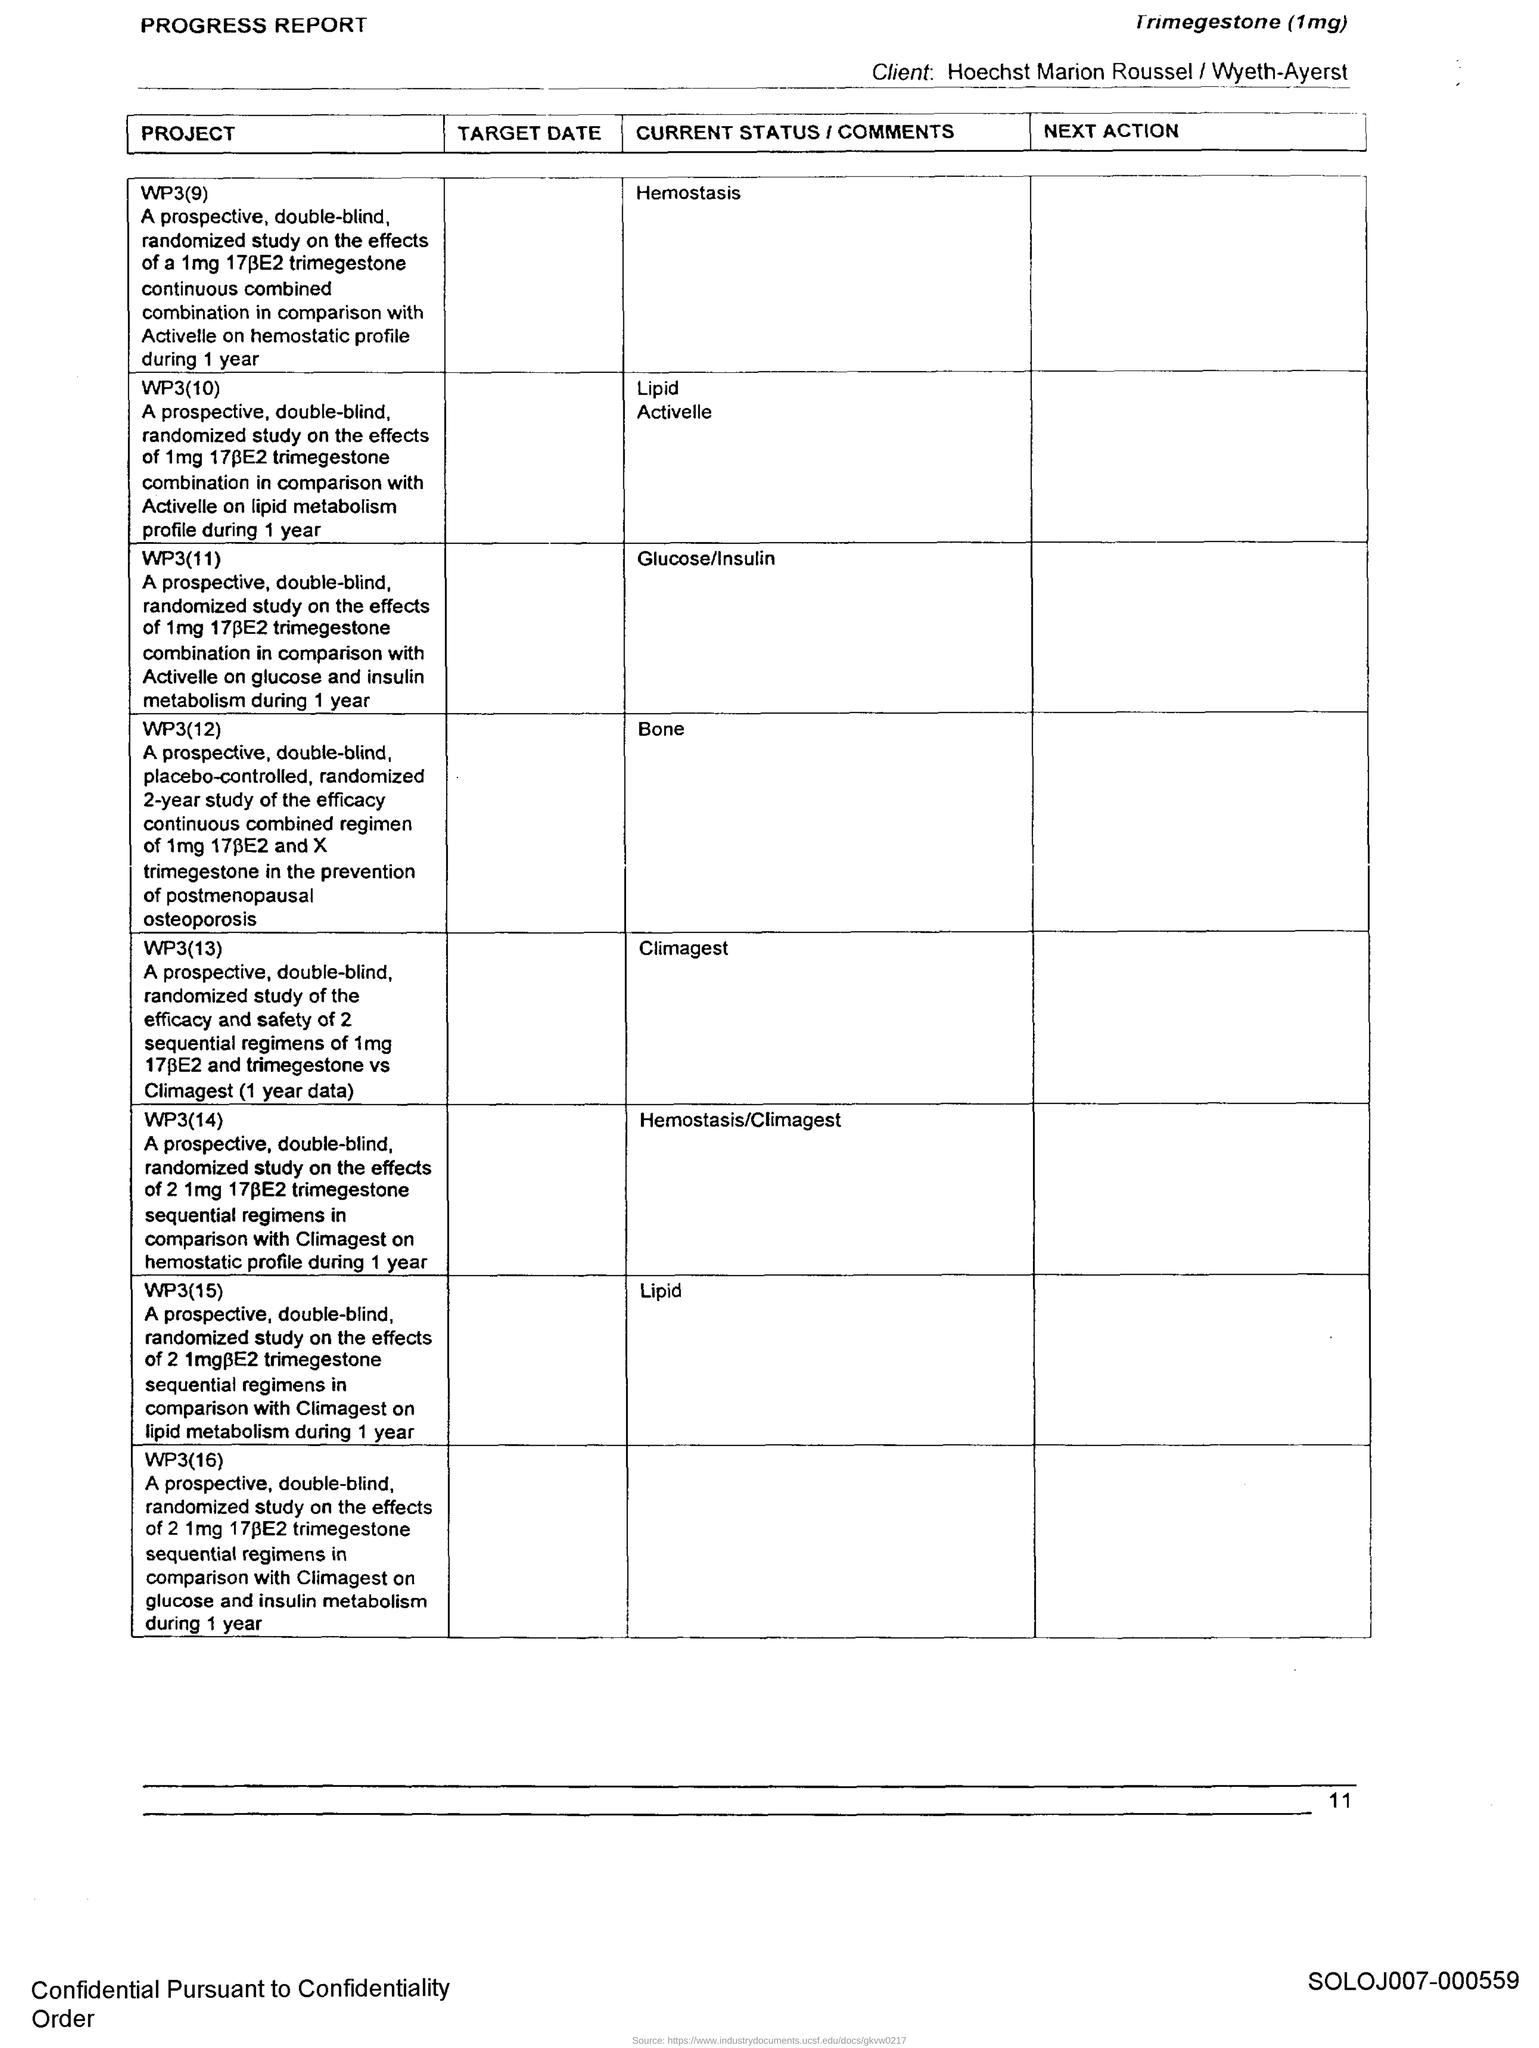What is the current status of PROJECT WP3(9)?
Provide a succinct answer. Hemostasis. What is the current status of PROJECT WP3(13)?
Make the answer very short. Climagest. 